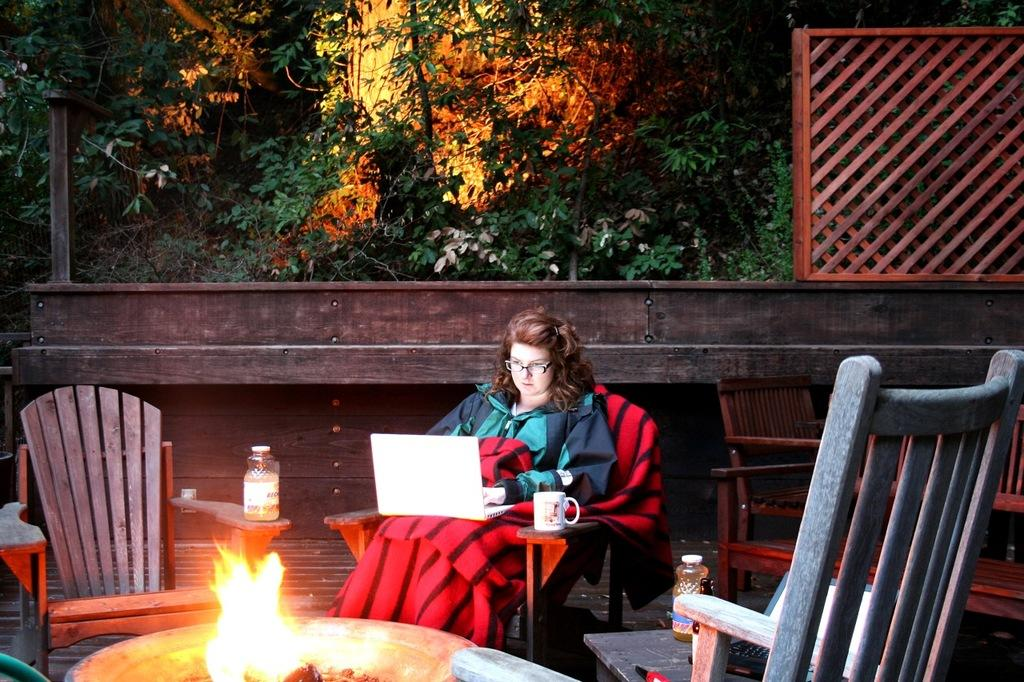Who is the main subject in the image? There is a woman in the image. What is the woman doing in the image? The woman is sitting on a chair. What object is the woman holding or using in the image? The woman has a laptop on her lap. What type of snail can be seen crawling on the woman's shoulder in the image? There is no snail present on the woman's shoulder in the image. Can you tell me what kind of cat is sitting next to the woman in the image? There is no cat present in the image. 